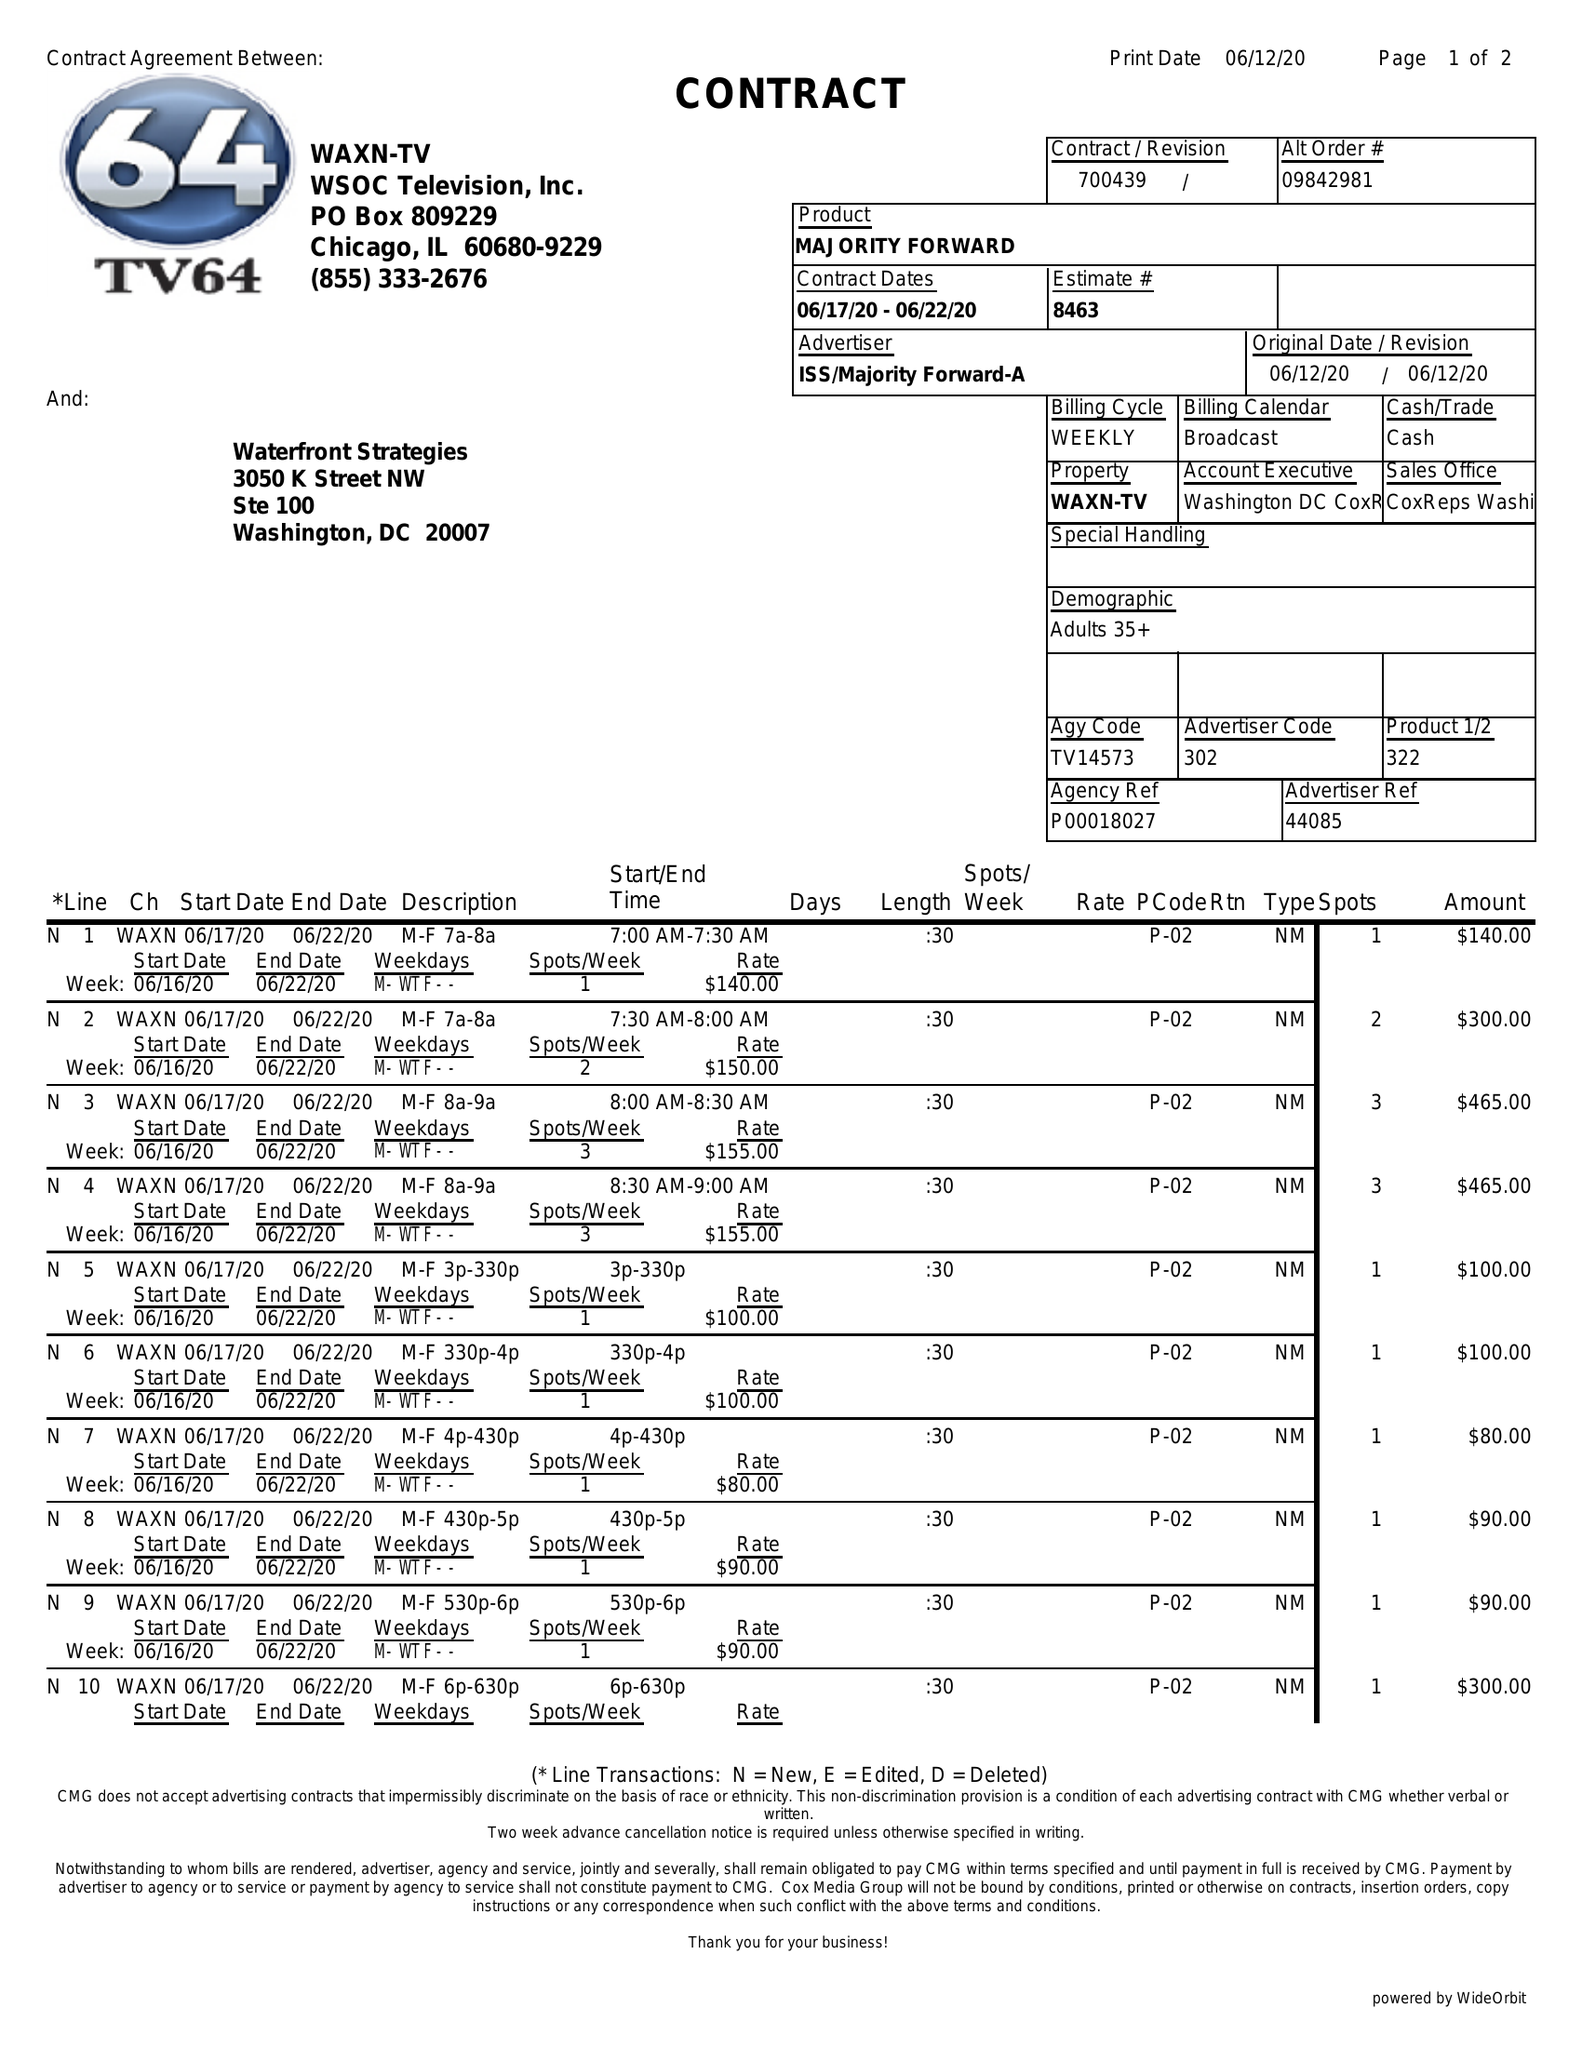What is the value for the advertiser?
Answer the question using a single word or phrase. ISS/MAJORITYFORWARD-A 